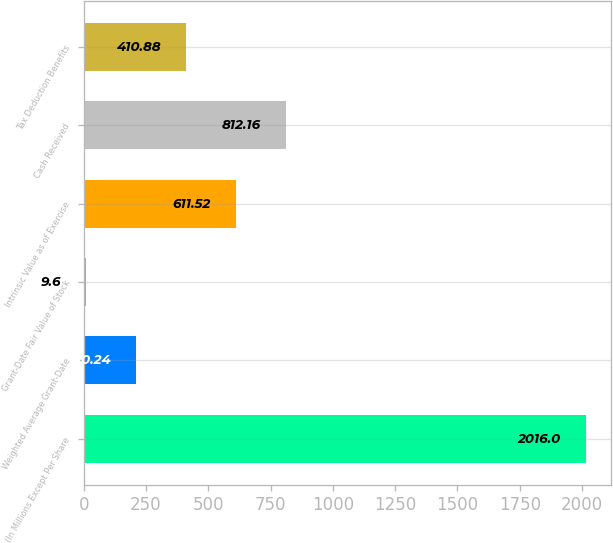Convert chart. <chart><loc_0><loc_0><loc_500><loc_500><bar_chart><fcel>(In Millions Except Per Share<fcel>Weighted Average Grant-Date<fcel>Grant-Date Fair Value of Stock<fcel>Intrinsic Value as of Exercise<fcel>Cash Received<fcel>Tax Deduction Benefits<nl><fcel>2016<fcel>210.24<fcel>9.6<fcel>611.52<fcel>812.16<fcel>410.88<nl></chart> 